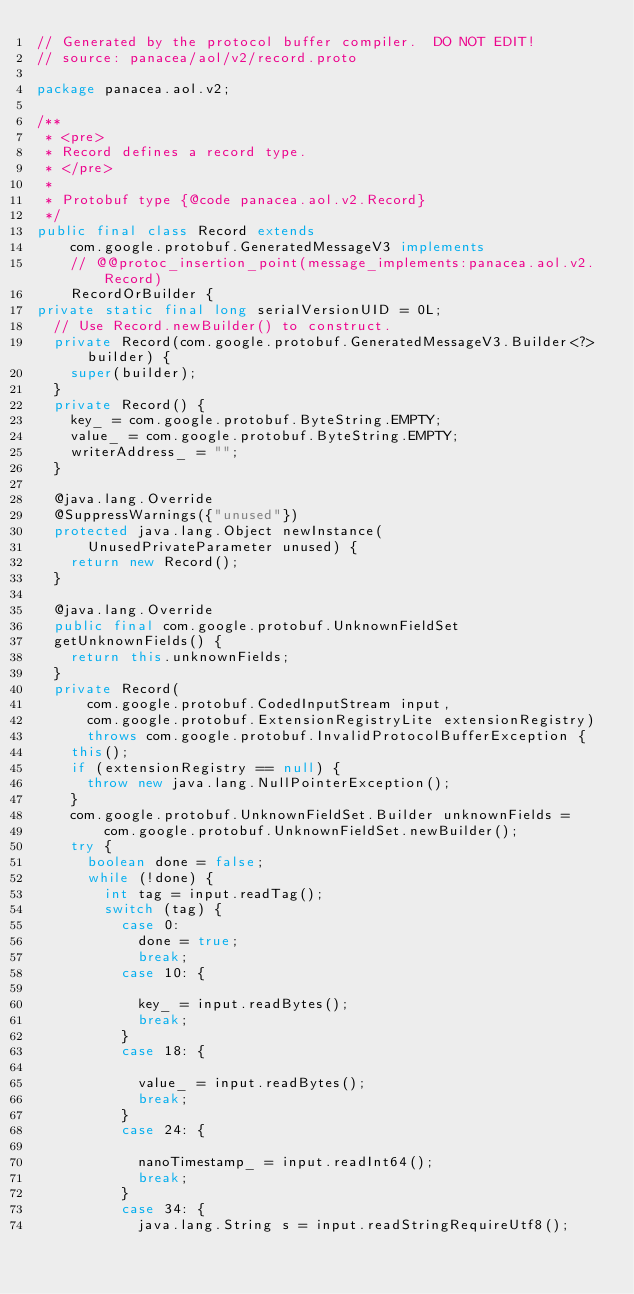<code> <loc_0><loc_0><loc_500><loc_500><_Java_>// Generated by the protocol buffer compiler.  DO NOT EDIT!
// source: panacea/aol/v2/record.proto

package panacea.aol.v2;

/**
 * <pre>
 * Record defines a record type.
 * </pre>
 *
 * Protobuf type {@code panacea.aol.v2.Record}
 */
public final class Record extends
    com.google.protobuf.GeneratedMessageV3 implements
    // @@protoc_insertion_point(message_implements:panacea.aol.v2.Record)
    RecordOrBuilder {
private static final long serialVersionUID = 0L;
  // Use Record.newBuilder() to construct.
  private Record(com.google.protobuf.GeneratedMessageV3.Builder<?> builder) {
    super(builder);
  }
  private Record() {
    key_ = com.google.protobuf.ByteString.EMPTY;
    value_ = com.google.protobuf.ByteString.EMPTY;
    writerAddress_ = "";
  }

  @java.lang.Override
  @SuppressWarnings({"unused"})
  protected java.lang.Object newInstance(
      UnusedPrivateParameter unused) {
    return new Record();
  }

  @java.lang.Override
  public final com.google.protobuf.UnknownFieldSet
  getUnknownFields() {
    return this.unknownFields;
  }
  private Record(
      com.google.protobuf.CodedInputStream input,
      com.google.protobuf.ExtensionRegistryLite extensionRegistry)
      throws com.google.protobuf.InvalidProtocolBufferException {
    this();
    if (extensionRegistry == null) {
      throw new java.lang.NullPointerException();
    }
    com.google.protobuf.UnknownFieldSet.Builder unknownFields =
        com.google.protobuf.UnknownFieldSet.newBuilder();
    try {
      boolean done = false;
      while (!done) {
        int tag = input.readTag();
        switch (tag) {
          case 0:
            done = true;
            break;
          case 10: {

            key_ = input.readBytes();
            break;
          }
          case 18: {

            value_ = input.readBytes();
            break;
          }
          case 24: {

            nanoTimestamp_ = input.readInt64();
            break;
          }
          case 34: {
            java.lang.String s = input.readStringRequireUtf8();
</code> 